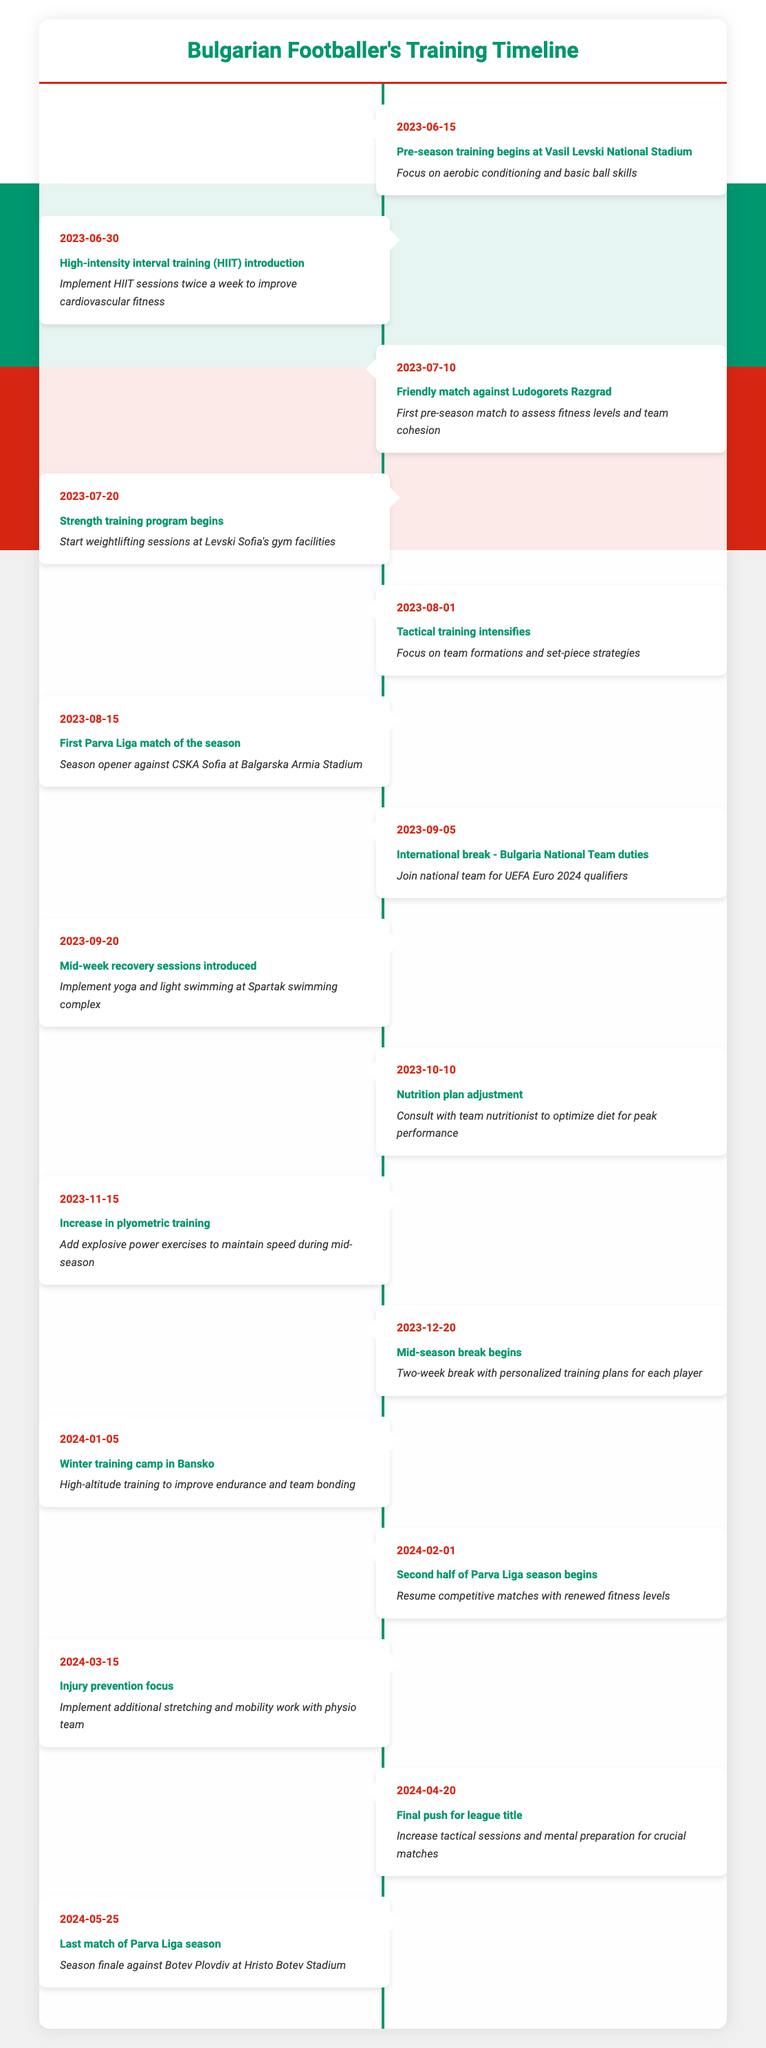What is the first training event in the timeline? The first event listed in the timeline is on June 15, 2023, which is the beginning of pre-season training at Vasil Levski National Stadium. The description states it focuses on aerobic conditioning and basic ball skills.
Answer: Pre-season training begins at Vasil Levski National Stadium What is the last match of the Parva Liga season? The last match of the Parva Liga season is on May 25, 2024, against Botev Plovdiv at Hristo Botev Stadium. This is specified as the season finale event in the timeline.
Answer: Last match of Parva Liga season against Botev Plovdiv What date does the mid-season break begin? The timeline indicates that the mid-season break begins on December 20, 2023, as noted in the event description.
Answer: 2023-12-20 Is there a training session focused on plyometric exercises? Yes, the timeline includes an increase in plyometric training on November 15, 2023, which aims to add explosive power exercises and maintain speed during the mid-season.
Answer: Yes What significant events take place in August 2023? In August 2023, two significant events occur: the first is an intensification of tactical training on August 1, where the focus is on team formations and set-piece strategies, followed by the first Parva Liga match of the season against CSKA Sofia on August 15. These events illustrate the transition from training to competitive matches.
Answer: Tactical training intensifies and first Parva Liga match How many weeks apart are the introduction of HIIT and the first friendly match? The introduction of HIIT is on June 30, 2023, and the first friendly match occurs on July 10, 2023. The duration between these dates is 10 days, which is approximately 1.43 weeks.
Answer: 1.43 weeks When does the nutrition plan adjustment happen, and why is it important? The nutrition plan adjustment occurs on October 10, 2023. It is important for optimizing the players' diets for peak performance, demonstrating the emphasis on nutrition in athlete training.
Answer: October 10, 2023; for peak performance What are the two main focuses during the mid-week recovery sessions introduced on September 20, 2023? The mid-week recovery sessions introduced on September 20, 2023, focus on yoga and light swimming, as indicated in the description. These activities are aimed at recovery and maintaining fitness levels.
Answer: Yoga and light swimming How many training events are focused on injury prevention in the timeline? There is one specific event focused on injury prevention, which occurs on March 15, 2024, aiming to implement additional stretching and mobility work with the physio team. This highlights the importance of injury prevention during the season.
Answer: One event What activities are included in the winter training camp in Bansko scheduled for January 5, 2024? The winter training camp scheduled for January 5, 2024, includes high-altitude training to improve endurance and foster team bonding, which is vital as the second half of the season approaches.
Answer: High-altitude training for endurance and team bonding 